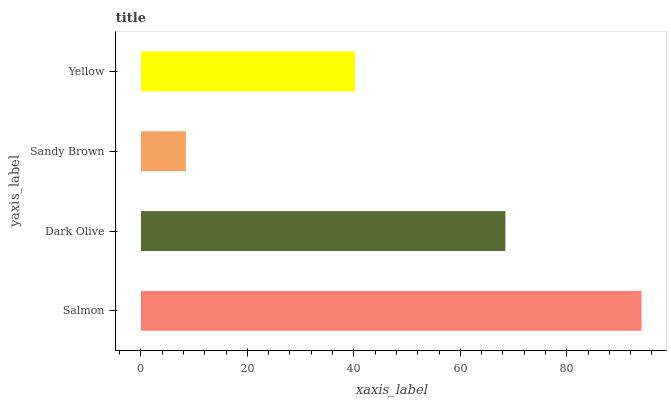Is Sandy Brown the minimum?
Answer yes or no. Yes. Is Salmon the maximum?
Answer yes or no. Yes. Is Dark Olive the minimum?
Answer yes or no. No. Is Dark Olive the maximum?
Answer yes or no. No. Is Salmon greater than Dark Olive?
Answer yes or no. Yes. Is Dark Olive less than Salmon?
Answer yes or no. Yes. Is Dark Olive greater than Salmon?
Answer yes or no. No. Is Salmon less than Dark Olive?
Answer yes or no. No. Is Dark Olive the high median?
Answer yes or no. Yes. Is Yellow the low median?
Answer yes or no. Yes. Is Sandy Brown the high median?
Answer yes or no. No. Is Salmon the low median?
Answer yes or no. No. 